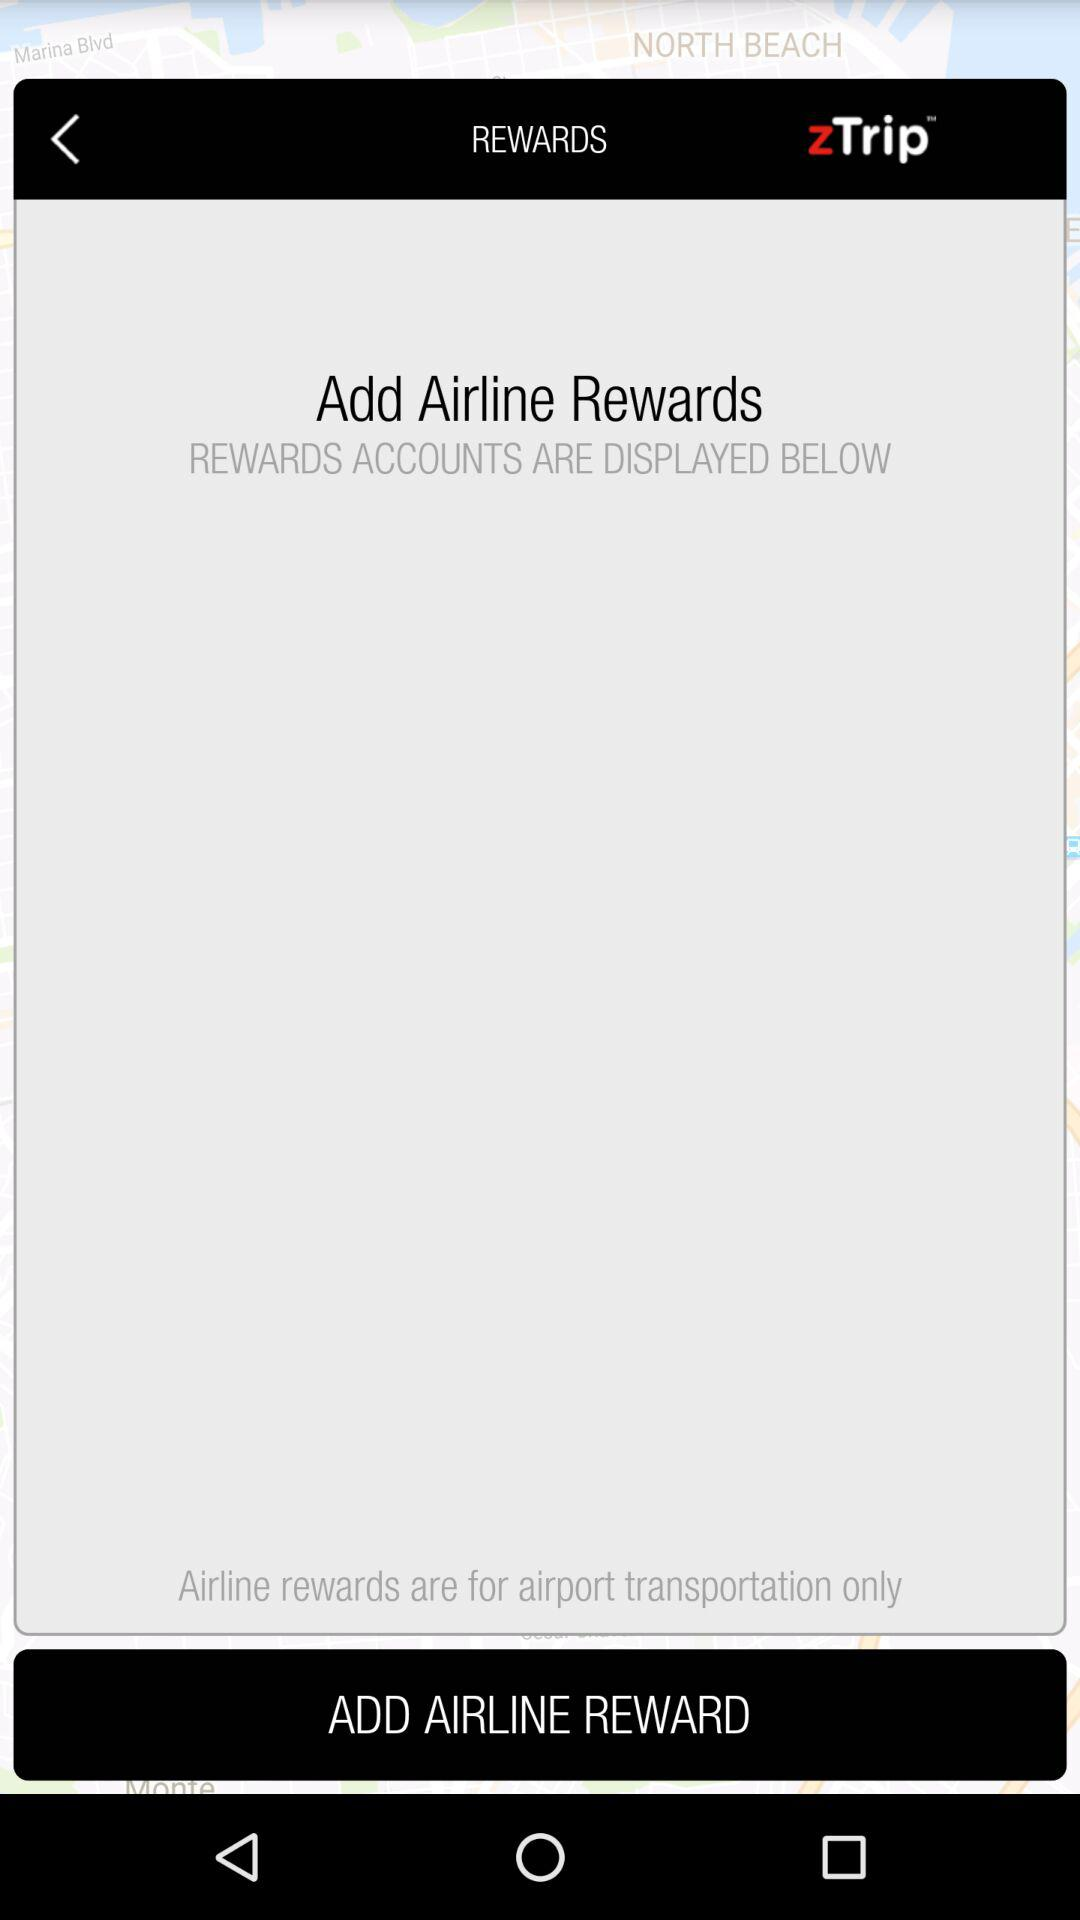Which airport is selected for the rewards?
When the provided information is insufficient, respond with <no answer>. <no answer> 